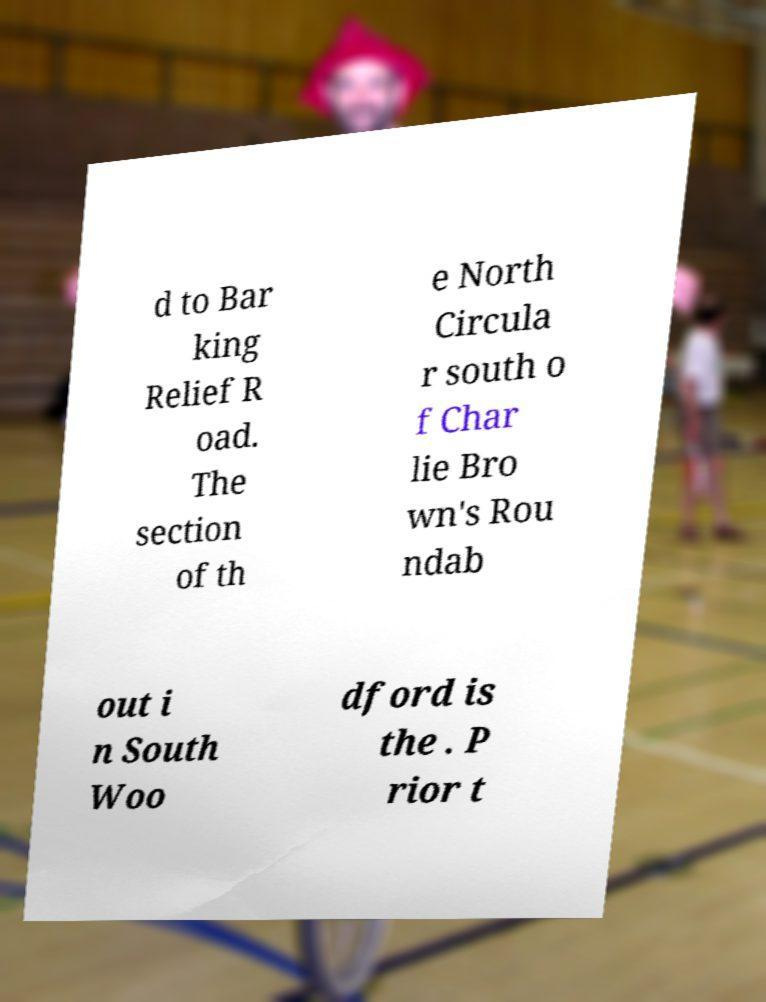Can you read and provide the text displayed in the image?This photo seems to have some interesting text. Can you extract and type it out for me? d to Bar king Relief R oad. The section of th e North Circula r south o f Char lie Bro wn's Rou ndab out i n South Woo dford is the . P rior t 